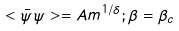<formula> <loc_0><loc_0><loc_500><loc_500>< \bar { \psi } \psi > = A m ^ { 1 / \delta } ; \beta = \beta _ { c }</formula> 